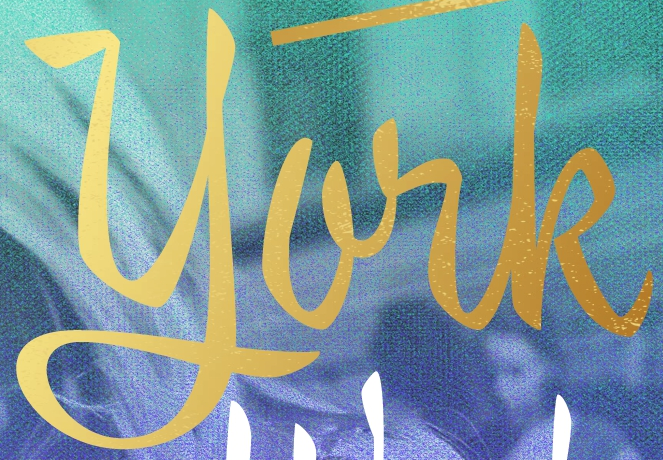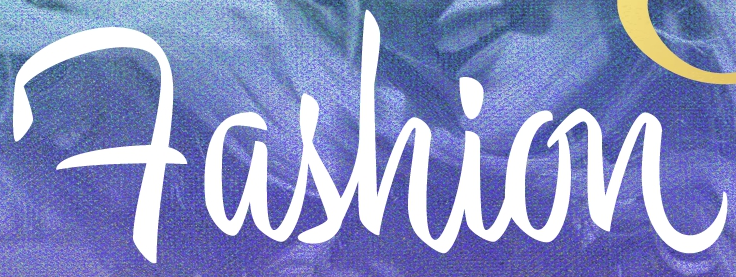Read the text content from these images in order, separated by a semicolon. york; Fashion 